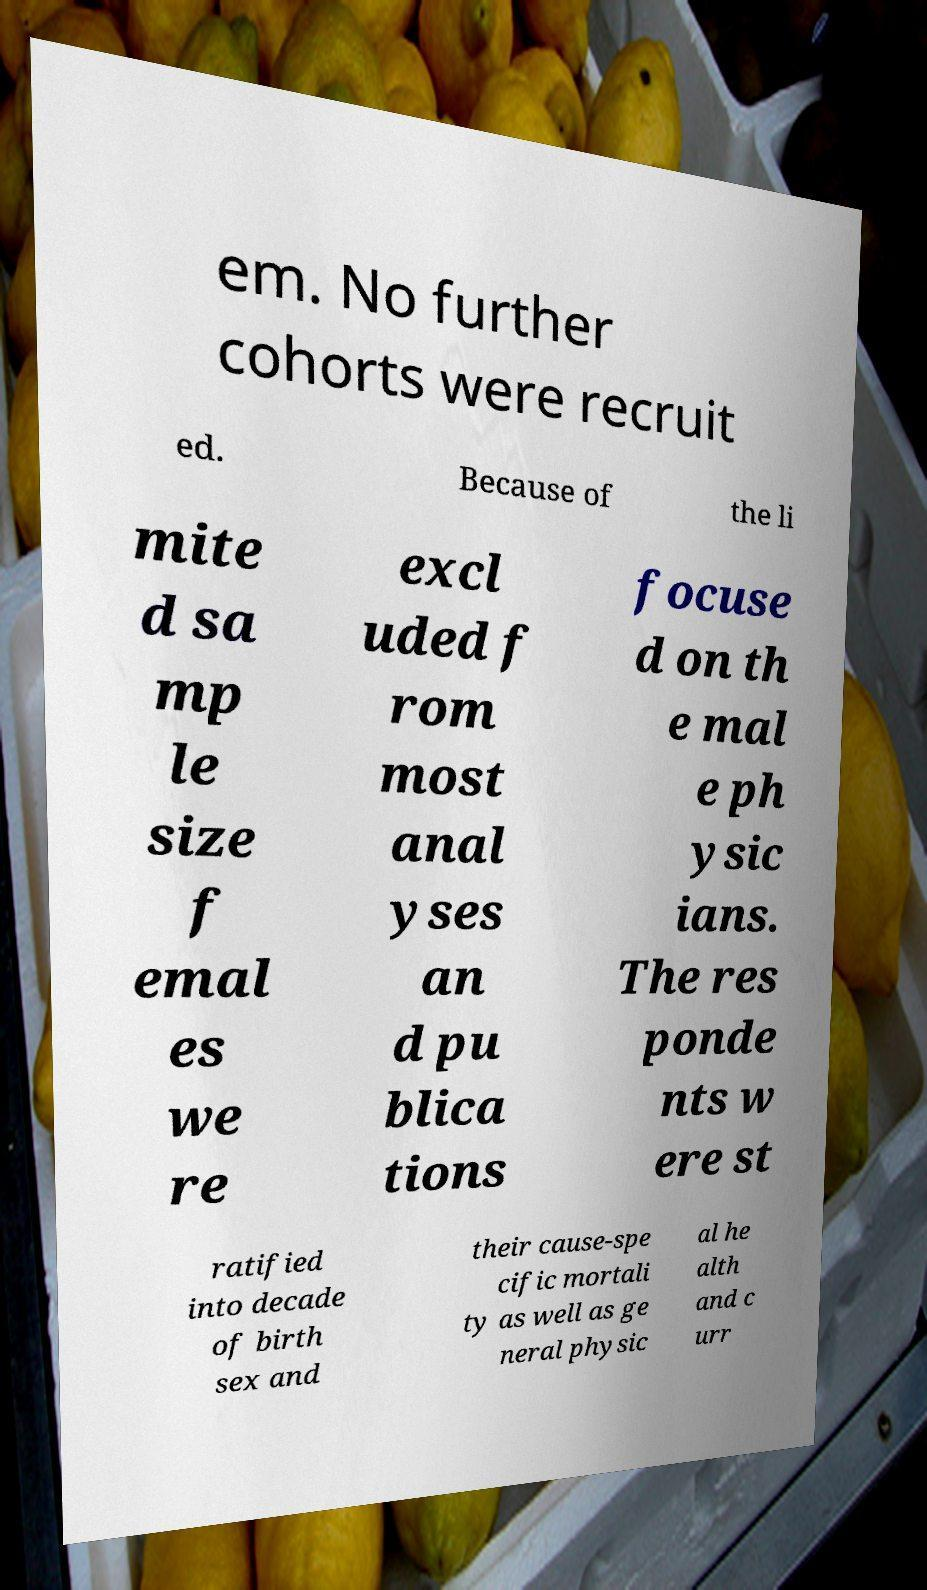I need the written content from this picture converted into text. Can you do that? em. No further cohorts were recruit ed. Because of the li mite d sa mp le size f emal es we re excl uded f rom most anal yses an d pu blica tions focuse d on th e mal e ph ysic ians. The res ponde nts w ere st ratified into decade of birth sex and their cause-spe cific mortali ty as well as ge neral physic al he alth and c urr 